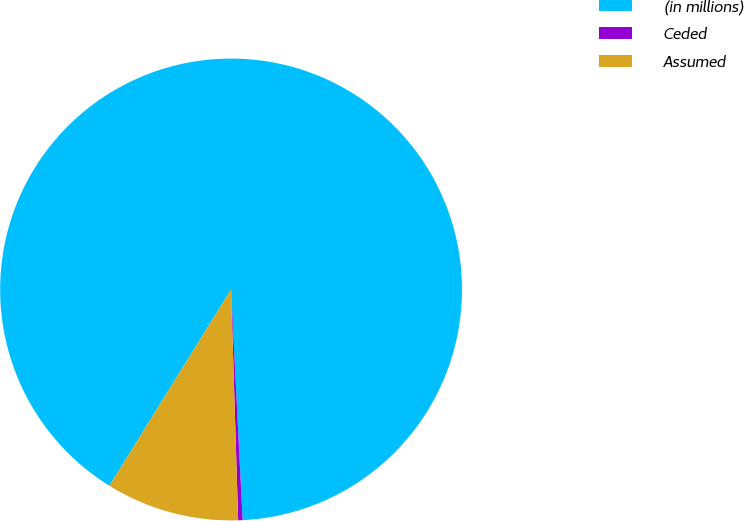<chart> <loc_0><loc_0><loc_500><loc_500><pie_chart><fcel>(in millions)<fcel>Ceded<fcel>Assumed<nl><fcel>90.37%<fcel>0.31%<fcel>9.32%<nl></chart> 